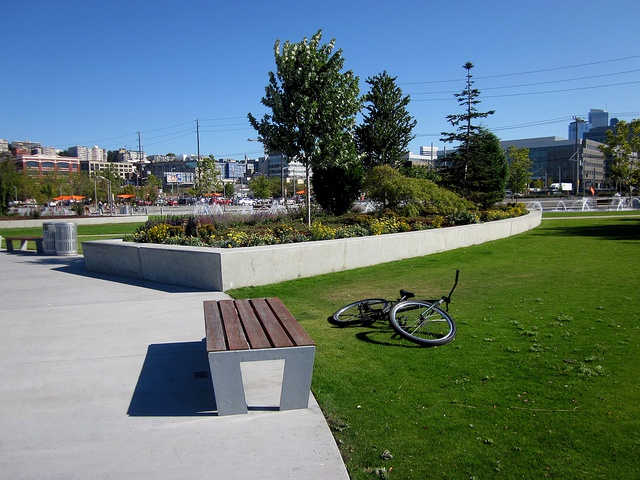Describe the objects in this image and their specific colors. I can see bench in blue and gray tones, bicycle in blue, black, darkgreen, and gray tones, and bench in blue, black, darkgreen, and gray tones in this image. 